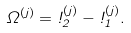Convert formula to latex. <formula><loc_0><loc_0><loc_500><loc_500>\Omega ^ { ( j ) } = \omega _ { 2 } ^ { ( j ) } - \omega _ { 1 } ^ { ( j ) } .</formula> 